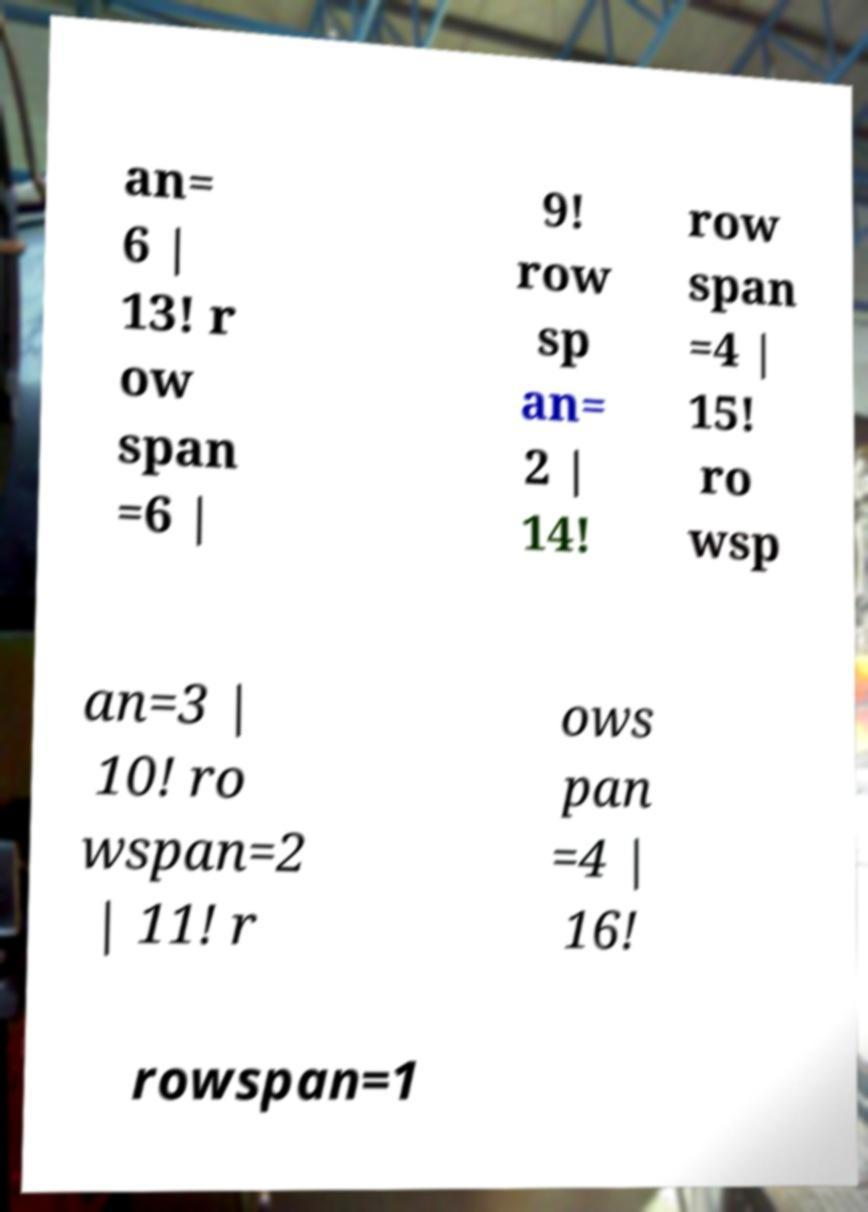I need the written content from this picture converted into text. Can you do that? an= 6 | 13! r ow span =6 | 9! row sp an= 2 | 14! row span =4 | 15! ro wsp an=3 | 10! ro wspan=2 | 11! r ows pan =4 | 16! rowspan=1 